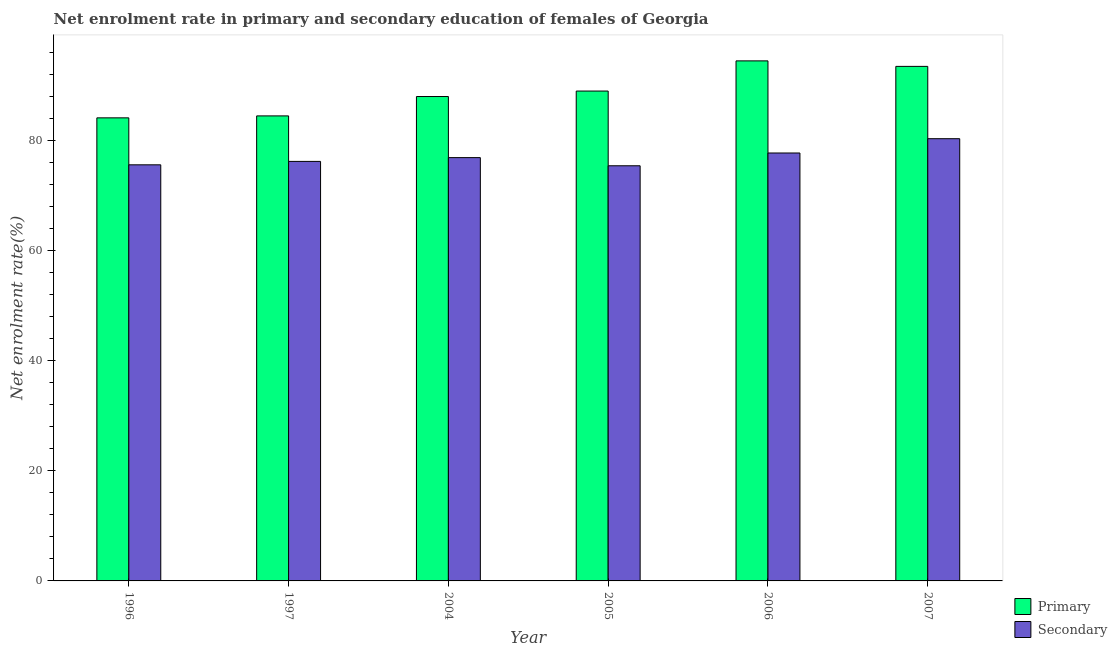How many different coloured bars are there?
Your response must be concise. 2. Are the number of bars per tick equal to the number of legend labels?
Keep it short and to the point. Yes. How many bars are there on the 6th tick from the left?
Provide a short and direct response. 2. How many bars are there on the 6th tick from the right?
Ensure brevity in your answer.  2. What is the enrollment rate in secondary education in 1996?
Ensure brevity in your answer.  75.6. Across all years, what is the maximum enrollment rate in secondary education?
Provide a short and direct response. 80.34. Across all years, what is the minimum enrollment rate in primary education?
Your answer should be very brief. 84.13. In which year was the enrollment rate in secondary education maximum?
Make the answer very short. 2007. In which year was the enrollment rate in primary education minimum?
Give a very brief answer. 1996. What is the total enrollment rate in secondary education in the graph?
Provide a short and direct response. 462.23. What is the difference between the enrollment rate in primary education in 1996 and that in 1997?
Ensure brevity in your answer.  -0.35. What is the difference between the enrollment rate in primary education in 2005 and the enrollment rate in secondary education in 2007?
Your response must be concise. -4.48. What is the average enrollment rate in primary education per year?
Ensure brevity in your answer.  88.93. What is the ratio of the enrollment rate in primary education in 1996 to that in 2004?
Keep it short and to the point. 0.96. Is the difference between the enrollment rate in secondary education in 2005 and 2006 greater than the difference between the enrollment rate in primary education in 2005 and 2006?
Ensure brevity in your answer.  No. What is the difference between the highest and the second highest enrollment rate in primary education?
Keep it short and to the point. 1. What is the difference between the highest and the lowest enrollment rate in primary education?
Offer a terse response. 10.35. In how many years, is the enrollment rate in secondary education greater than the average enrollment rate in secondary education taken over all years?
Offer a very short reply. 2. What does the 2nd bar from the left in 1997 represents?
Your response must be concise. Secondary. What does the 1st bar from the right in 1997 represents?
Your answer should be compact. Secondary. How many bars are there?
Your response must be concise. 12. Are all the bars in the graph horizontal?
Your answer should be very brief. No. Are the values on the major ticks of Y-axis written in scientific E-notation?
Your answer should be very brief. No. Does the graph contain grids?
Provide a short and direct response. No. How are the legend labels stacked?
Provide a short and direct response. Vertical. What is the title of the graph?
Offer a terse response. Net enrolment rate in primary and secondary education of females of Georgia. What is the label or title of the X-axis?
Your answer should be very brief. Year. What is the label or title of the Y-axis?
Your answer should be very brief. Net enrolment rate(%). What is the Net enrolment rate(%) of Primary in 1996?
Your answer should be compact. 84.13. What is the Net enrolment rate(%) in Secondary in 1996?
Your answer should be very brief. 75.6. What is the Net enrolment rate(%) of Primary in 1997?
Offer a very short reply. 84.48. What is the Net enrolment rate(%) of Secondary in 1997?
Give a very brief answer. 76.22. What is the Net enrolment rate(%) in Primary in 2004?
Provide a short and direct response. 88. What is the Net enrolment rate(%) in Secondary in 2004?
Ensure brevity in your answer.  76.9. What is the Net enrolment rate(%) of Primary in 2005?
Give a very brief answer. 89. What is the Net enrolment rate(%) in Secondary in 2005?
Keep it short and to the point. 75.42. What is the Net enrolment rate(%) of Primary in 2006?
Offer a very short reply. 94.48. What is the Net enrolment rate(%) in Secondary in 2006?
Offer a very short reply. 77.75. What is the Net enrolment rate(%) of Primary in 2007?
Ensure brevity in your answer.  93.48. What is the Net enrolment rate(%) of Secondary in 2007?
Your response must be concise. 80.34. Across all years, what is the maximum Net enrolment rate(%) of Primary?
Your answer should be very brief. 94.48. Across all years, what is the maximum Net enrolment rate(%) in Secondary?
Your answer should be very brief. 80.34. Across all years, what is the minimum Net enrolment rate(%) in Primary?
Provide a succinct answer. 84.13. Across all years, what is the minimum Net enrolment rate(%) in Secondary?
Keep it short and to the point. 75.42. What is the total Net enrolment rate(%) in Primary in the graph?
Offer a terse response. 533.57. What is the total Net enrolment rate(%) in Secondary in the graph?
Provide a short and direct response. 462.23. What is the difference between the Net enrolment rate(%) in Primary in 1996 and that in 1997?
Your answer should be compact. -0.35. What is the difference between the Net enrolment rate(%) of Secondary in 1996 and that in 1997?
Your answer should be compact. -0.62. What is the difference between the Net enrolment rate(%) of Primary in 1996 and that in 2004?
Provide a short and direct response. -3.87. What is the difference between the Net enrolment rate(%) in Secondary in 1996 and that in 2004?
Give a very brief answer. -1.31. What is the difference between the Net enrolment rate(%) of Primary in 1996 and that in 2005?
Offer a terse response. -4.87. What is the difference between the Net enrolment rate(%) in Secondary in 1996 and that in 2005?
Provide a succinct answer. 0.17. What is the difference between the Net enrolment rate(%) in Primary in 1996 and that in 2006?
Give a very brief answer. -10.35. What is the difference between the Net enrolment rate(%) of Secondary in 1996 and that in 2006?
Offer a very short reply. -2.15. What is the difference between the Net enrolment rate(%) in Primary in 1996 and that in 2007?
Ensure brevity in your answer.  -9.35. What is the difference between the Net enrolment rate(%) of Secondary in 1996 and that in 2007?
Make the answer very short. -4.75. What is the difference between the Net enrolment rate(%) in Primary in 1997 and that in 2004?
Make the answer very short. -3.52. What is the difference between the Net enrolment rate(%) in Secondary in 1997 and that in 2004?
Offer a very short reply. -0.69. What is the difference between the Net enrolment rate(%) in Primary in 1997 and that in 2005?
Keep it short and to the point. -4.51. What is the difference between the Net enrolment rate(%) in Secondary in 1997 and that in 2005?
Give a very brief answer. 0.79. What is the difference between the Net enrolment rate(%) of Primary in 1997 and that in 2006?
Give a very brief answer. -10. What is the difference between the Net enrolment rate(%) in Secondary in 1997 and that in 2006?
Keep it short and to the point. -1.53. What is the difference between the Net enrolment rate(%) of Primary in 1997 and that in 2007?
Keep it short and to the point. -9. What is the difference between the Net enrolment rate(%) of Secondary in 1997 and that in 2007?
Offer a terse response. -4.12. What is the difference between the Net enrolment rate(%) in Primary in 2004 and that in 2005?
Provide a short and direct response. -0.99. What is the difference between the Net enrolment rate(%) of Secondary in 2004 and that in 2005?
Keep it short and to the point. 1.48. What is the difference between the Net enrolment rate(%) of Primary in 2004 and that in 2006?
Provide a succinct answer. -6.48. What is the difference between the Net enrolment rate(%) in Secondary in 2004 and that in 2006?
Make the answer very short. -0.84. What is the difference between the Net enrolment rate(%) of Primary in 2004 and that in 2007?
Provide a succinct answer. -5.48. What is the difference between the Net enrolment rate(%) in Secondary in 2004 and that in 2007?
Offer a terse response. -3.44. What is the difference between the Net enrolment rate(%) in Primary in 2005 and that in 2006?
Offer a terse response. -5.48. What is the difference between the Net enrolment rate(%) in Secondary in 2005 and that in 2006?
Your response must be concise. -2.32. What is the difference between the Net enrolment rate(%) of Primary in 2005 and that in 2007?
Offer a very short reply. -4.48. What is the difference between the Net enrolment rate(%) of Secondary in 2005 and that in 2007?
Provide a short and direct response. -4.92. What is the difference between the Net enrolment rate(%) in Secondary in 2006 and that in 2007?
Your answer should be compact. -2.6. What is the difference between the Net enrolment rate(%) of Primary in 1996 and the Net enrolment rate(%) of Secondary in 1997?
Make the answer very short. 7.91. What is the difference between the Net enrolment rate(%) in Primary in 1996 and the Net enrolment rate(%) in Secondary in 2004?
Provide a short and direct response. 7.22. What is the difference between the Net enrolment rate(%) of Primary in 1996 and the Net enrolment rate(%) of Secondary in 2005?
Your response must be concise. 8.71. What is the difference between the Net enrolment rate(%) in Primary in 1996 and the Net enrolment rate(%) in Secondary in 2006?
Offer a terse response. 6.38. What is the difference between the Net enrolment rate(%) in Primary in 1996 and the Net enrolment rate(%) in Secondary in 2007?
Keep it short and to the point. 3.79. What is the difference between the Net enrolment rate(%) of Primary in 1997 and the Net enrolment rate(%) of Secondary in 2004?
Ensure brevity in your answer.  7.58. What is the difference between the Net enrolment rate(%) of Primary in 1997 and the Net enrolment rate(%) of Secondary in 2005?
Provide a succinct answer. 9.06. What is the difference between the Net enrolment rate(%) in Primary in 1997 and the Net enrolment rate(%) in Secondary in 2006?
Provide a succinct answer. 6.74. What is the difference between the Net enrolment rate(%) of Primary in 1997 and the Net enrolment rate(%) of Secondary in 2007?
Your response must be concise. 4.14. What is the difference between the Net enrolment rate(%) in Primary in 2004 and the Net enrolment rate(%) in Secondary in 2005?
Your answer should be very brief. 12.58. What is the difference between the Net enrolment rate(%) of Primary in 2004 and the Net enrolment rate(%) of Secondary in 2006?
Make the answer very short. 10.26. What is the difference between the Net enrolment rate(%) in Primary in 2004 and the Net enrolment rate(%) in Secondary in 2007?
Offer a very short reply. 7.66. What is the difference between the Net enrolment rate(%) of Primary in 2005 and the Net enrolment rate(%) of Secondary in 2006?
Keep it short and to the point. 11.25. What is the difference between the Net enrolment rate(%) of Primary in 2005 and the Net enrolment rate(%) of Secondary in 2007?
Keep it short and to the point. 8.66. What is the difference between the Net enrolment rate(%) in Primary in 2006 and the Net enrolment rate(%) in Secondary in 2007?
Offer a very short reply. 14.14. What is the average Net enrolment rate(%) of Primary per year?
Your answer should be compact. 88.93. What is the average Net enrolment rate(%) of Secondary per year?
Make the answer very short. 77.04. In the year 1996, what is the difference between the Net enrolment rate(%) of Primary and Net enrolment rate(%) of Secondary?
Offer a terse response. 8.53. In the year 1997, what is the difference between the Net enrolment rate(%) in Primary and Net enrolment rate(%) in Secondary?
Ensure brevity in your answer.  8.27. In the year 2004, what is the difference between the Net enrolment rate(%) of Primary and Net enrolment rate(%) of Secondary?
Your response must be concise. 11.1. In the year 2005, what is the difference between the Net enrolment rate(%) of Primary and Net enrolment rate(%) of Secondary?
Your answer should be very brief. 13.57. In the year 2006, what is the difference between the Net enrolment rate(%) in Primary and Net enrolment rate(%) in Secondary?
Offer a very short reply. 16.74. In the year 2007, what is the difference between the Net enrolment rate(%) in Primary and Net enrolment rate(%) in Secondary?
Offer a very short reply. 13.14. What is the ratio of the Net enrolment rate(%) in Primary in 1996 to that in 1997?
Offer a terse response. 1. What is the ratio of the Net enrolment rate(%) in Primary in 1996 to that in 2004?
Keep it short and to the point. 0.96. What is the ratio of the Net enrolment rate(%) of Primary in 1996 to that in 2005?
Give a very brief answer. 0.95. What is the ratio of the Net enrolment rate(%) of Primary in 1996 to that in 2006?
Offer a terse response. 0.89. What is the ratio of the Net enrolment rate(%) of Secondary in 1996 to that in 2006?
Provide a succinct answer. 0.97. What is the ratio of the Net enrolment rate(%) of Primary in 1996 to that in 2007?
Your response must be concise. 0.9. What is the ratio of the Net enrolment rate(%) of Secondary in 1996 to that in 2007?
Your answer should be compact. 0.94. What is the ratio of the Net enrolment rate(%) in Secondary in 1997 to that in 2004?
Provide a short and direct response. 0.99. What is the ratio of the Net enrolment rate(%) in Primary in 1997 to that in 2005?
Your response must be concise. 0.95. What is the ratio of the Net enrolment rate(%) of Secondary in 1997 to that in 2005?
Give a very brief answer. 1.01. What is the ratio of the Net enrolment rate(%) of Primary in 1997 to that in 2006?
Your answer should be very brief. 0.89. What is the ratio of the Net enrolment rate(%) of Secondary in 1997 to that in 2006?
Provide a succinct answer. 0.98. What is the ratio of the Net enrolment rate(%) in Primary in 1997 to that in 2007?
Provide a short and direct response. 0.9. What is the ratio of the Net enrolment rate(%) of Secondary in 1997 to that in 2007?
Your answer should be very brief. 0.95. What is the ratio of the Net enrolment rate(%) of Primary in 2004 to that in 2005?
Give a very brief answer. 0.99. What is the ratio of the Net enrolment rate(%) of Secondary in 2004 to that in 2005?
Your answer should be compact. 1.02. What is the ratio of the Net enrolment rate(%) of Primary in 2004 to that in 2006?
Make the answer very short. 0.93. What is the ratio of the Net enrolment rate(%) in Secondary in 2004 to that in 2006?
Your answer should be very brief. 0.99. What is the ratio of the Net enrolment rate(%) in Primary in 2004 to that in 2007?
Keep it short and to the point. 0.94. What is the ratio of the Net enrolment rate(%) of Secondary in 2004 to that in 2007?
Make the answer very short. 0.96. What is the ratio of the Net enrolment rate(%) of Primary in 2005 to that in 2006?
Your answer should be compact. 0.94. What is the ratio of the Net enrolment rate(%) of Secondary in 2005 to that in 2006?
Provide a short and direct response. 0.97. What is the ratio of the Net enrolment rate(%) of Primary in 2005 to that in 2007?
Ensure brevity in your answer.  0.95. What is the ratio of the Net enrolment rate(%) in Secondary in 2005 to that in 2007?
Make the answer very short. 0.94. What is the ratio of the Net enrolment rate(%) in Primary in 2006 to that in 2007?
Provide a succinct answer. 1.01. What is the ratio of the Net enrolment rate(%) in Secondary in 2006 to that in 2007?
Provide a succinct answer. 0.97. What is the difference between the highest and the second highest Net enrolment rate(%) in Secondary?
Offer a terse response. 2.6. What is the difference between the highest and the lowest Net enrolment rate(%) of Primary?
Provide a short and direct response. 10.35. What is the difference between the highest and the lowest Net enrolment rate(%) in Secondary?
Provide a succinct answer. 4.92. 